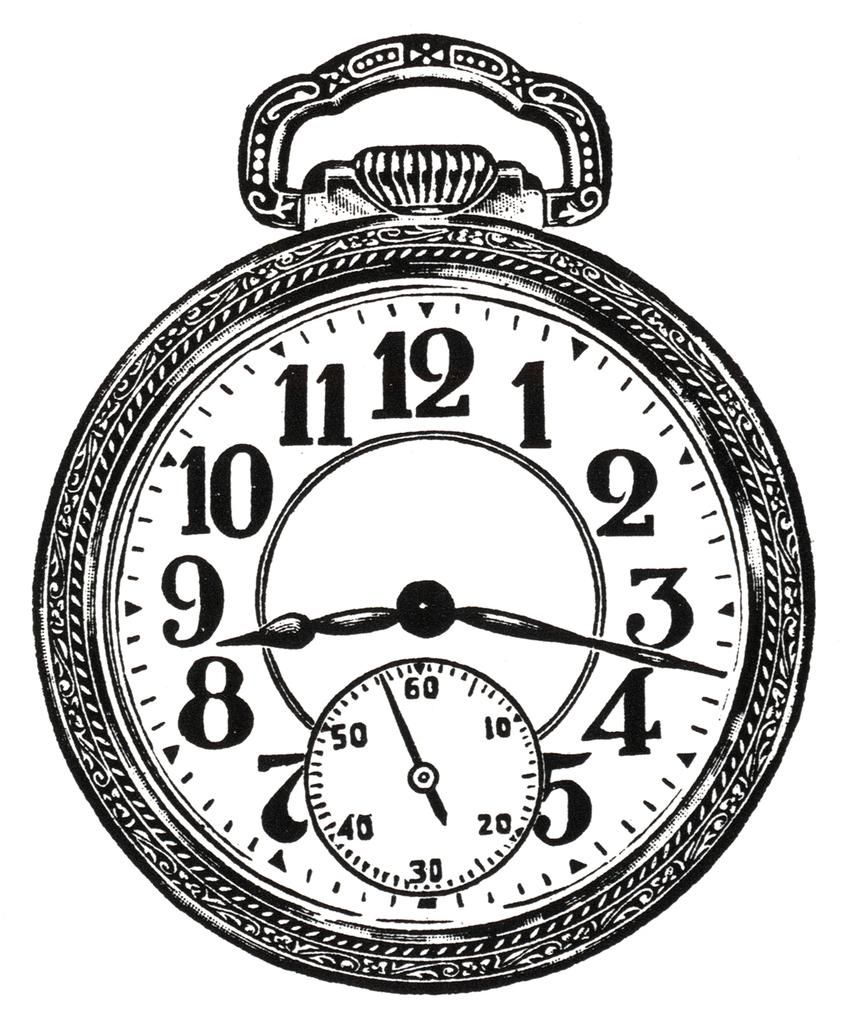<image>
Provide a brief description of the given image. A print of a clock features the traditional dial and a smaller dial for seconds with the numbers 10, 20, 30, 40, 50 and 60 on it. 